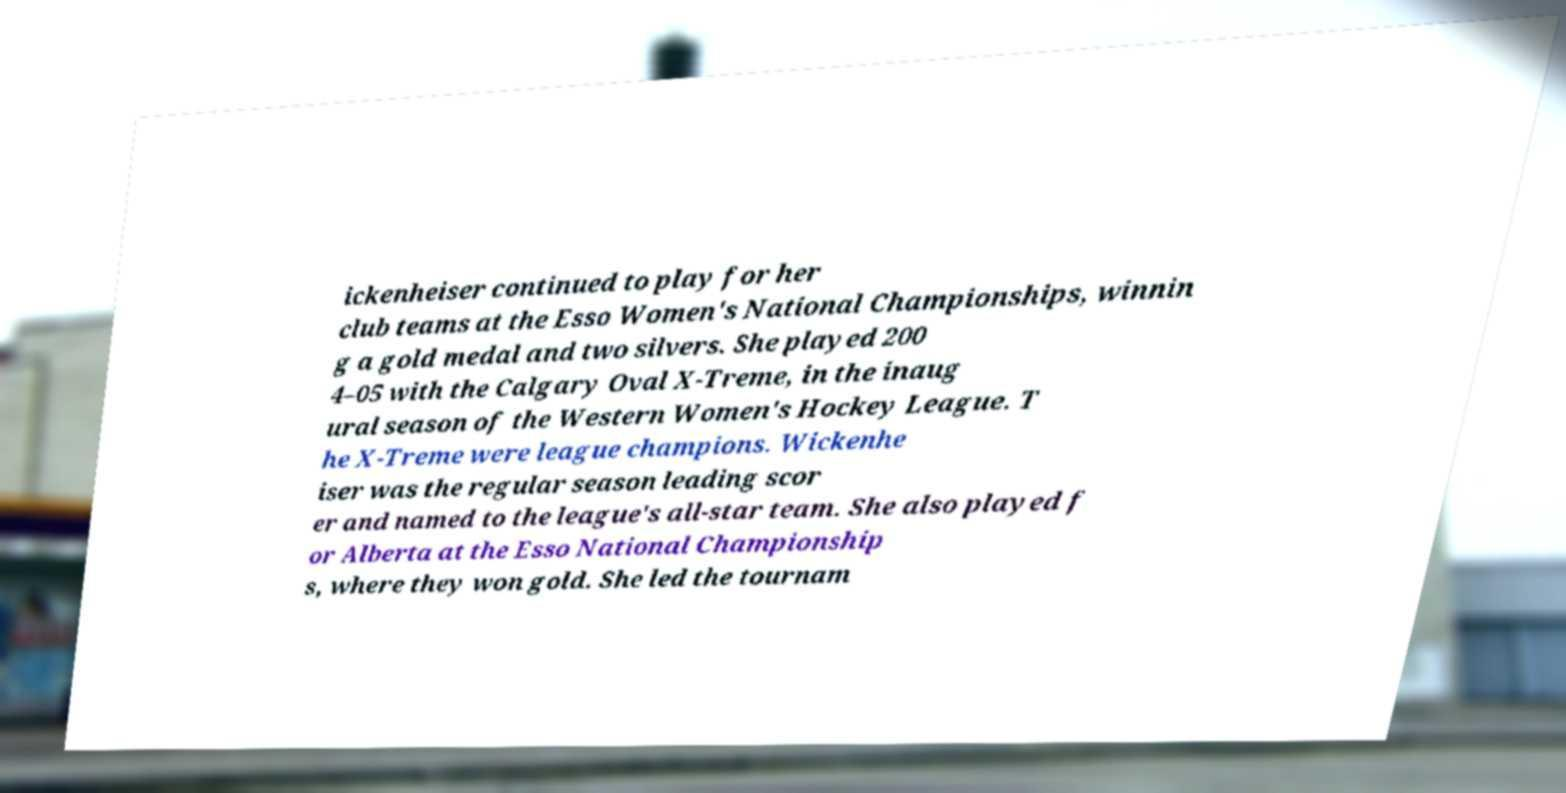What messages or text are displayed in this image? I need them in a readable, typed format. ickenheiser continued to play for her club teams at the Esso Women's National Championships, winnin g a gold medal and two silvers. She played 200 4–05 with the Calgary Oval X-Treme, in the inaug ural season of the Western Women's Hockey League. T he X-Treme were league champions. Wickenhe iser was the regular season leading scor er and named to the league's all-star team. She also played f or Alberta at the Esso National Championship s, where they won gold. She led the tournam 